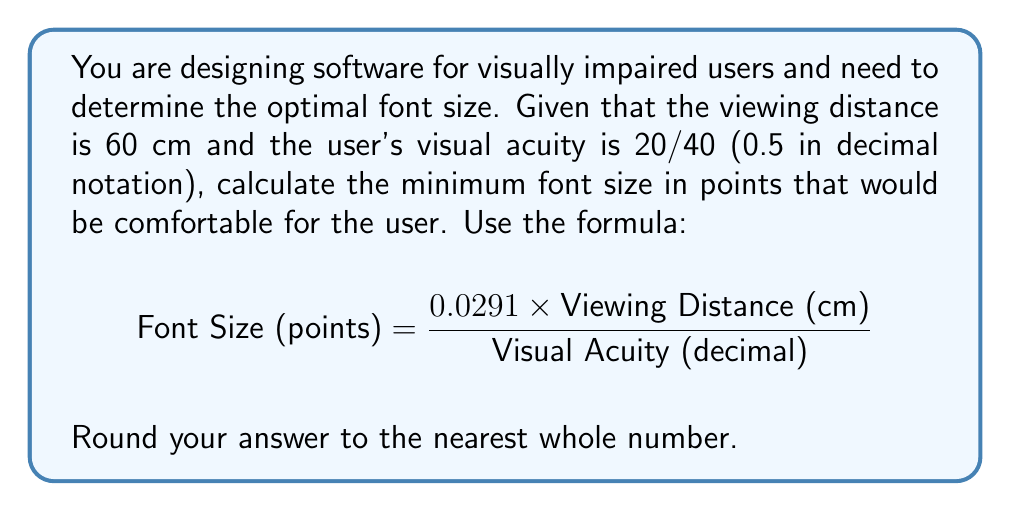What is the answer to this math problem? Let's approach this step-by-step:

1) We are given:
   - Viewing Distance = 60 cm
   - Visual Acuity = 20/40 = 0.5 (in decimal notation)

2) Let's substitute these values into the formula:

   $$ \text{Font Size (points)} = \frac{0.0291 \times 60}{0.5} $$

3) First, let's multiply 0.0291 by 60:
   
   $$ \text{Font Size (points)} = \frac{1.746}{0.5} $$

4) Now, let's divide 1.746 by 0.5:

   $$ \text{Font Size (points)} = 3.492 $$

5) The question asks to round to the nearest whole number:

   3.492 rounds up to 4

Therefore, the minimum comfortable font size for this user would be 4 points.
Answer: 4 points 